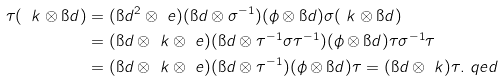<formula> <loc_0><loc_0><loc_500><loc_500>\tau ( \ k \otimes \i d ) & = ( \i d ^ { 2 } \otimes \ e ) ( \i d \otimes \sigma ^ { - 1 } ) ( \phi \otimes \i d ) \sigma ( \ k \otimes \i d ) \\ & = ( \i d \otimes \ k \otimes \ e ) ( \i d \otimes \tau ^ { - 1 } \sigma \tau ^ { - 1 } ) ( \phi \otimes \i d ) \tau \sigma ^ { - 1 } \tau \\ & = ( \i d \otimes \ k \otimes \ e ) ( \i d \otimes \tau ^ { - 1 } ) ( \phi \otimes \i d ) \tau = ( \i d \otimes \ k ) \tau . \ q e d</formula> 